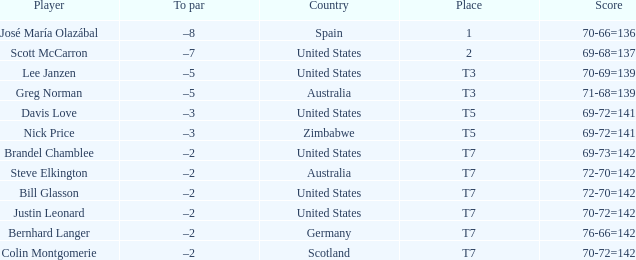Name the Player who has a To par of –2 and a Score of 69-73=142? Brandel Chamblee. 